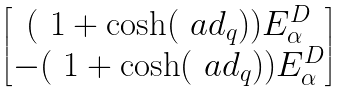Convert formula to latex. <formula><loc_0><loc_0><loc_500><loc_500>\begin{bmatrix} ( \ 1 + \cosh ( \ a d _ { q } ) ) E _ { \alpha } ^ { D } \\ - ( \ 1 + \cosh ( \ a d _ { q } ) ) E _ { \alpha } ^ { D } \end{bmatrix}</formula> 